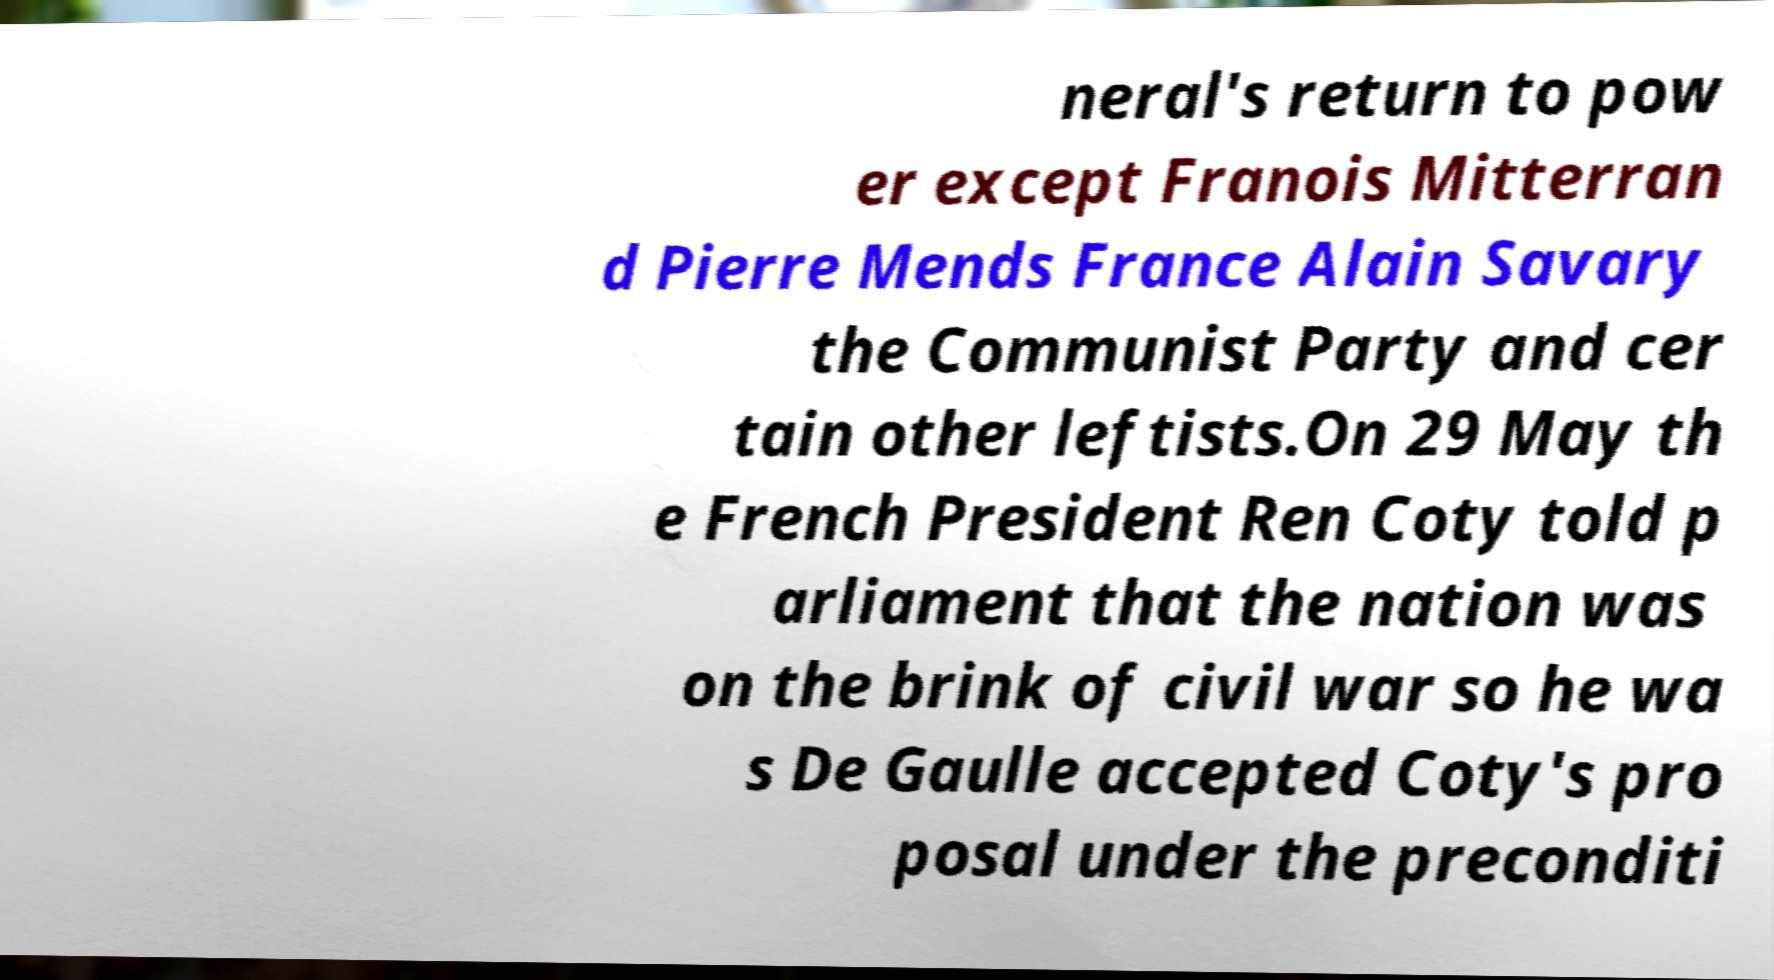Could you assist in decoding the text presented in this image and type it out clearly? neral's return to pow er except Franois Mitterran d Pierre Mends France Alain Savary the Communist Party and cer tain other leftists.On 29 May th e French President Ren Coty told p arliament that the nation was on the brink of civil war so he wa s De Gaulle accepted Coty's pro posal under the preconditi 